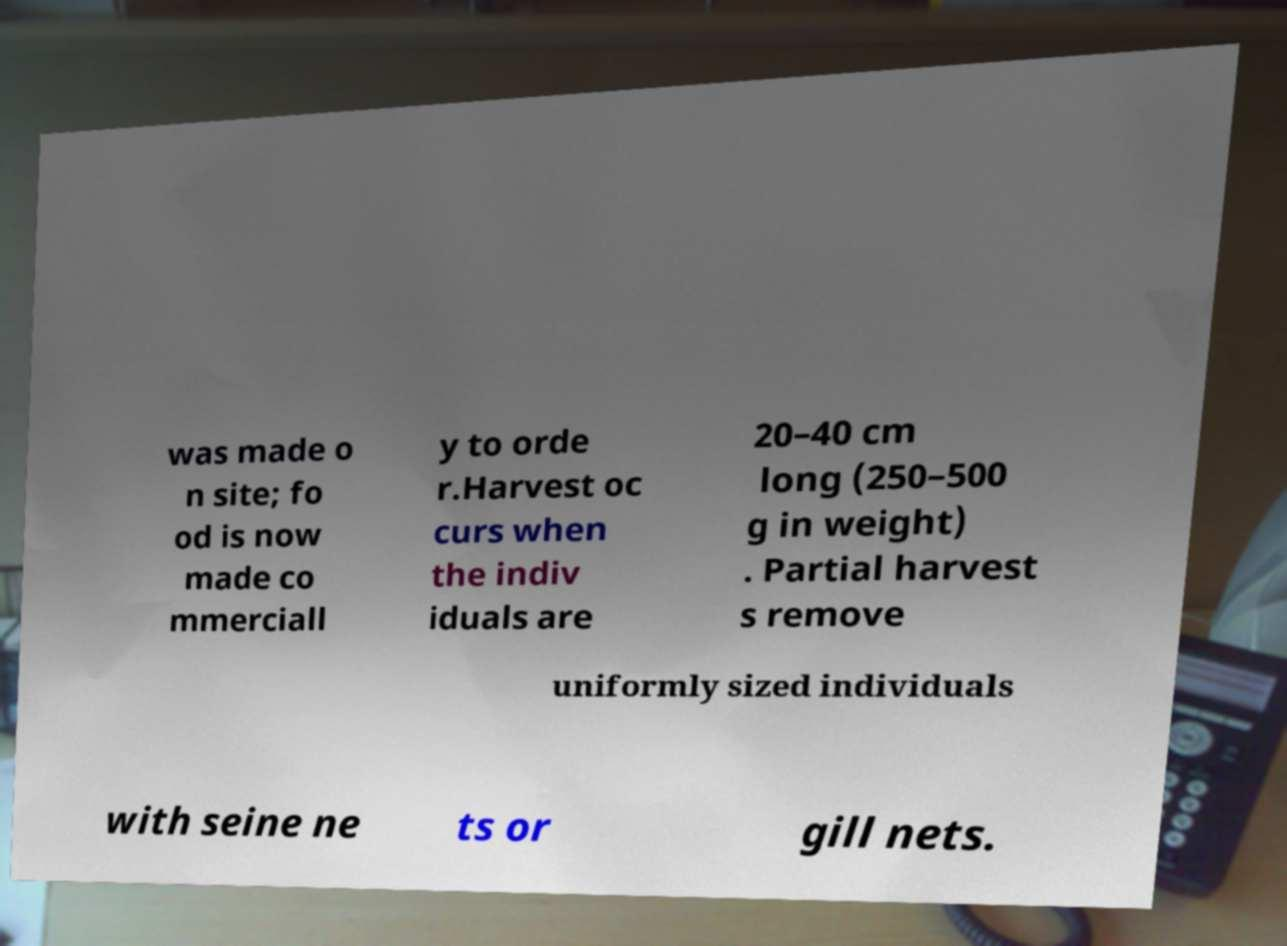Could you assist in decoding the text presented in this image and type it out clearly? was made o n site; fo od is now made co mmerciall y to orde r.Harvest oc curs when the indiv iduals are 20–40 cm long (250–500 g in weight) . Partial harvest s remove uniformly sized individuals with seine ne ts or gill nets. 